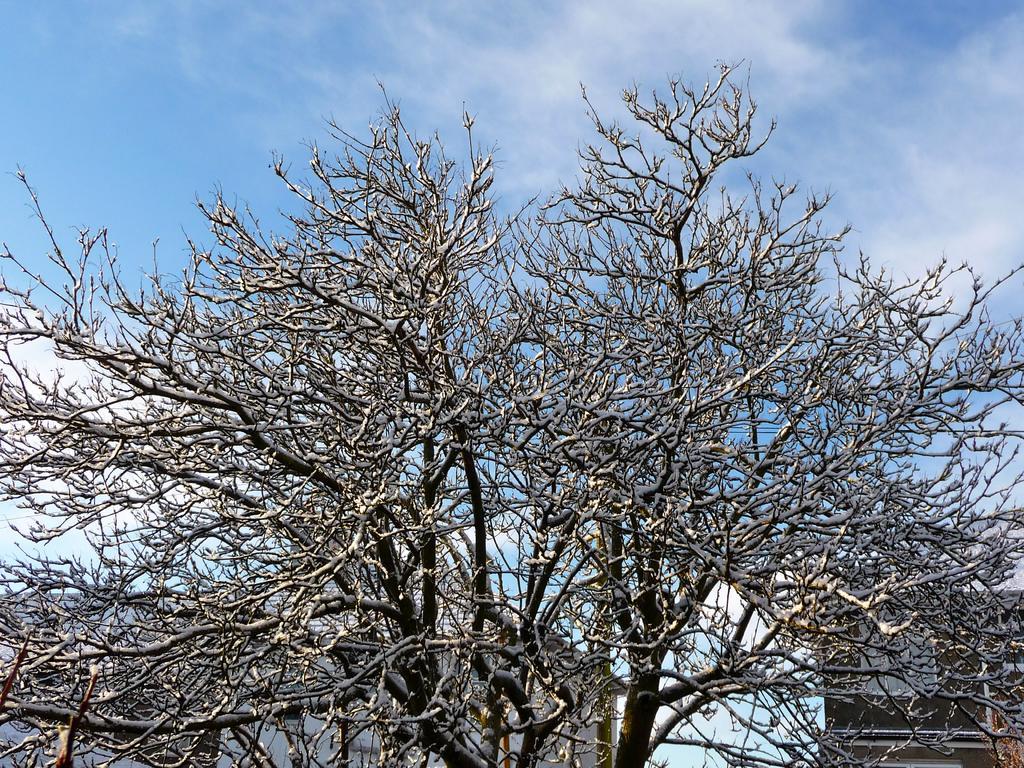Please provide a concise description of this image. In this picture we can see trees and in the background we can see some objects and sky with clouds. 